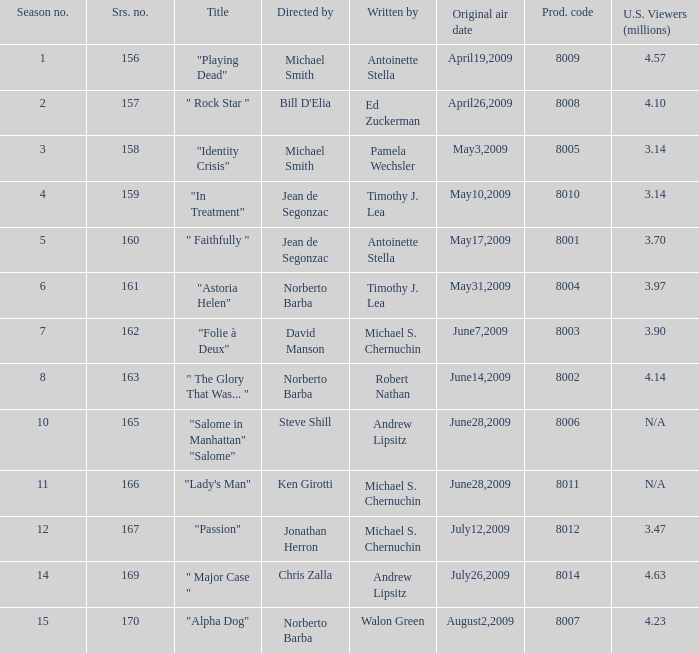Who are the writer of the series episode number 170? Walon Green. 